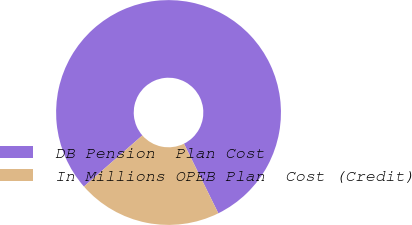Convert chart to OTSL. <chart><loc_0><loc_0><loc_500><loc_500><pie_chart><fcel>DB Pension  Plan Cost<fcel>In Millions OPEB Plan  Cost (Credit)<nl><fcel>79.14%<fcel>20.86%<nl></chart> 